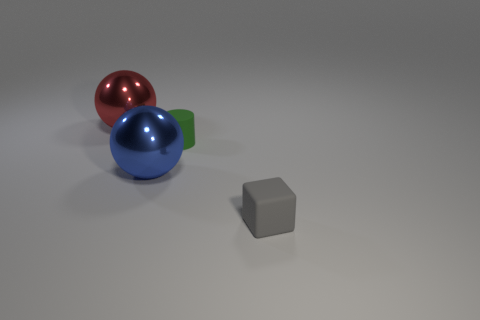There is another big object that is the same shape as the red shiny thing; what is its color?
Your answer should be compact. Blue. Do the ball left of the blue sphere and the gray block have the same material?
Provide a succinct answer. No. How many rubber objects have the same size as the green matte cylinder?
Offer a terse response. 1. Is the number of big red metallic objects that are right of the cube the same as the number of matte cylinders?
Provide a succinct answer. No. What number of objects are both on the left side of the gray rubber cube and on the right side of the blue object?
Provide a short and direct response. 1. There is a thing that is made of the same material as the blue sphere; what is its size?
Provide a succinct answer. Large. How many other objects have the same shape as the blue shiny object?
Your answer should be compact. 1. Are there more large metallic objects that are in front of the small gray block than big red metal balls?
Keep it short and to the point. No. There is a object that is both right of the red thing and behind the blue object; what shape is it?
Keep it short and to the point. Cylinder. Do the blue metal sphere and the red object have the same size?
Ensure brevity in your answer.  Yes. 